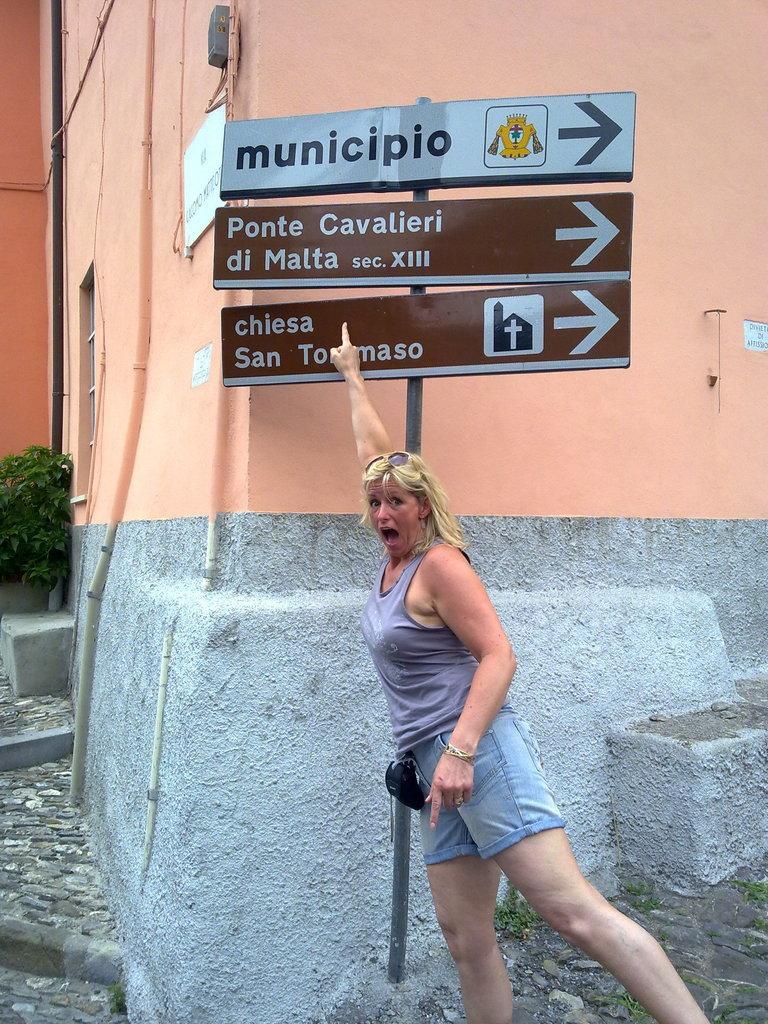Please provide a concise description of this image. In this picture I can observe a woman. I can observe three boards fixed to the pole in the middle of the picture. There is some text on these boards. On the left side there are some plants. In the background I can observe a building. 